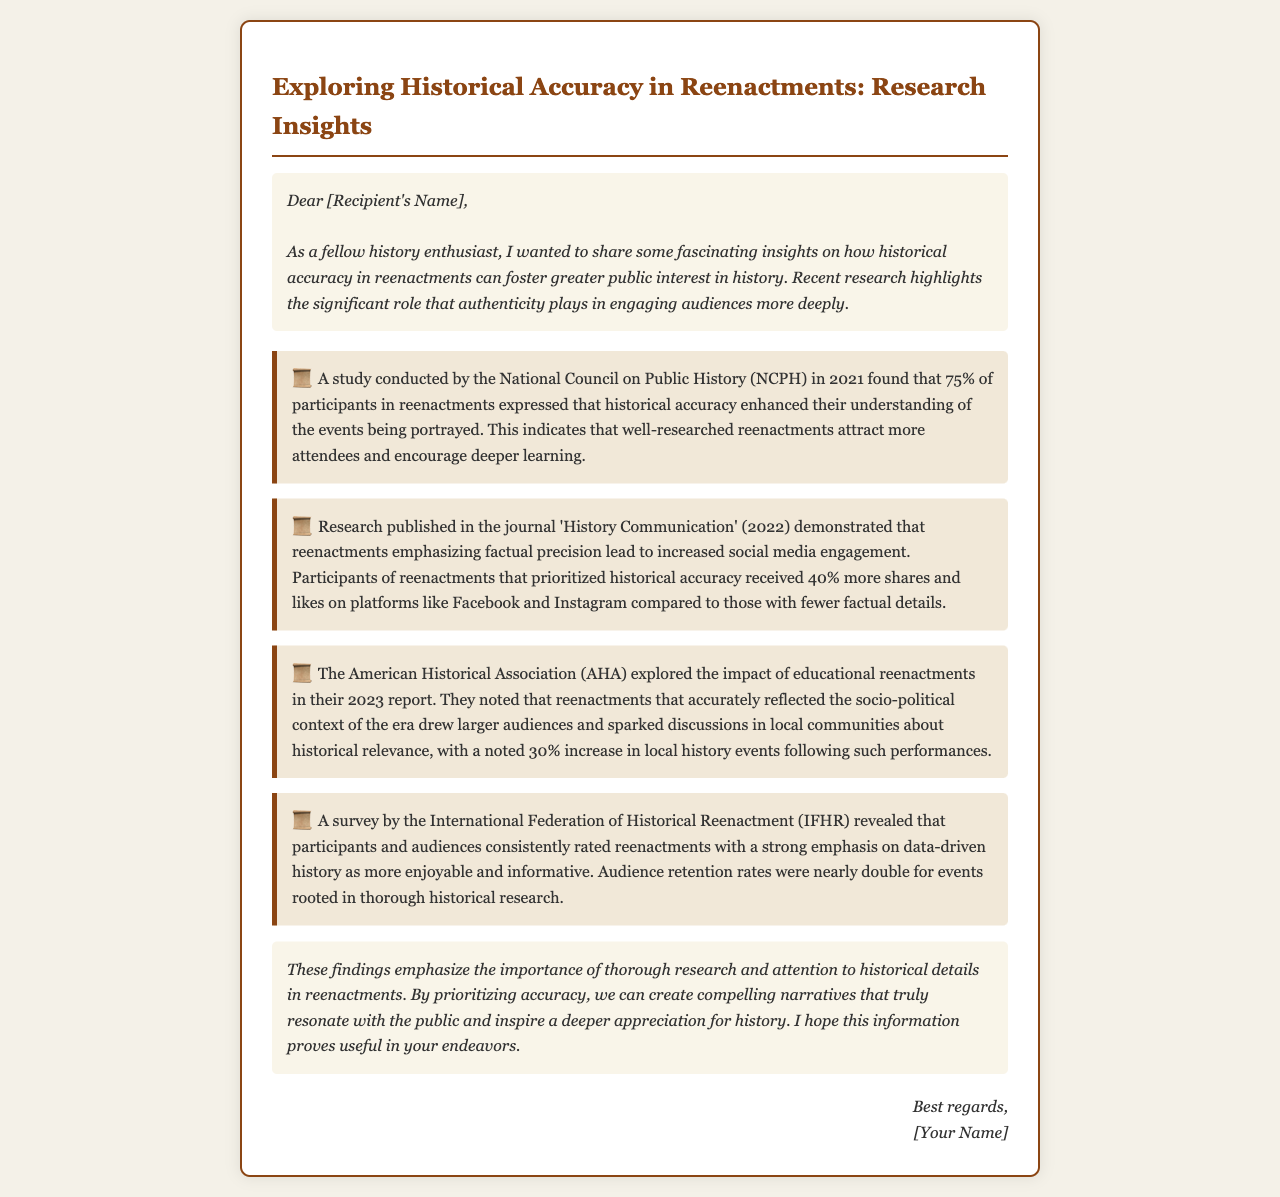What percentage of participants found historical accuracy enhanced their understanding? The document states that 75% of participants in reenactments expressed that historical accuracy enhanced their understanding.
Answer: 75% What was the increase in social media engagement for accurate reenactments? The document reveals that reenactments emphasizing factual precision led to a 40% increase in shares and likes on social media.
Answer: 40% Which organization conducted a study on the impact of educational reenactments in 2023? The American Historical Association (AHA) explored the impact of educational reenactments in their 2023 report.
Answer: American Historical Association (AHA) What was the audience retention rate difference for historically accurate events? The document mentions that audience retention rates were nearly double for events rooted in thorough historical research.
Answer: Nearly double What is the main benefit of prioritizing accuracy in reenactments according to the findings? The findings emphasize that prioritizing accuracy creates compelling narratives that resonate with the public and inspire appreciation for history.
Answer: Compelling narratives 